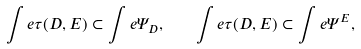<formula> <loc_0><loc_0><loc_500><loc_500>\int e \tau ( D , E ) \subset \int e \Psi _ { D } , \quad \int e \tau ( D , E ) \subset \int e \Psi ^ { E } ,</formula> 